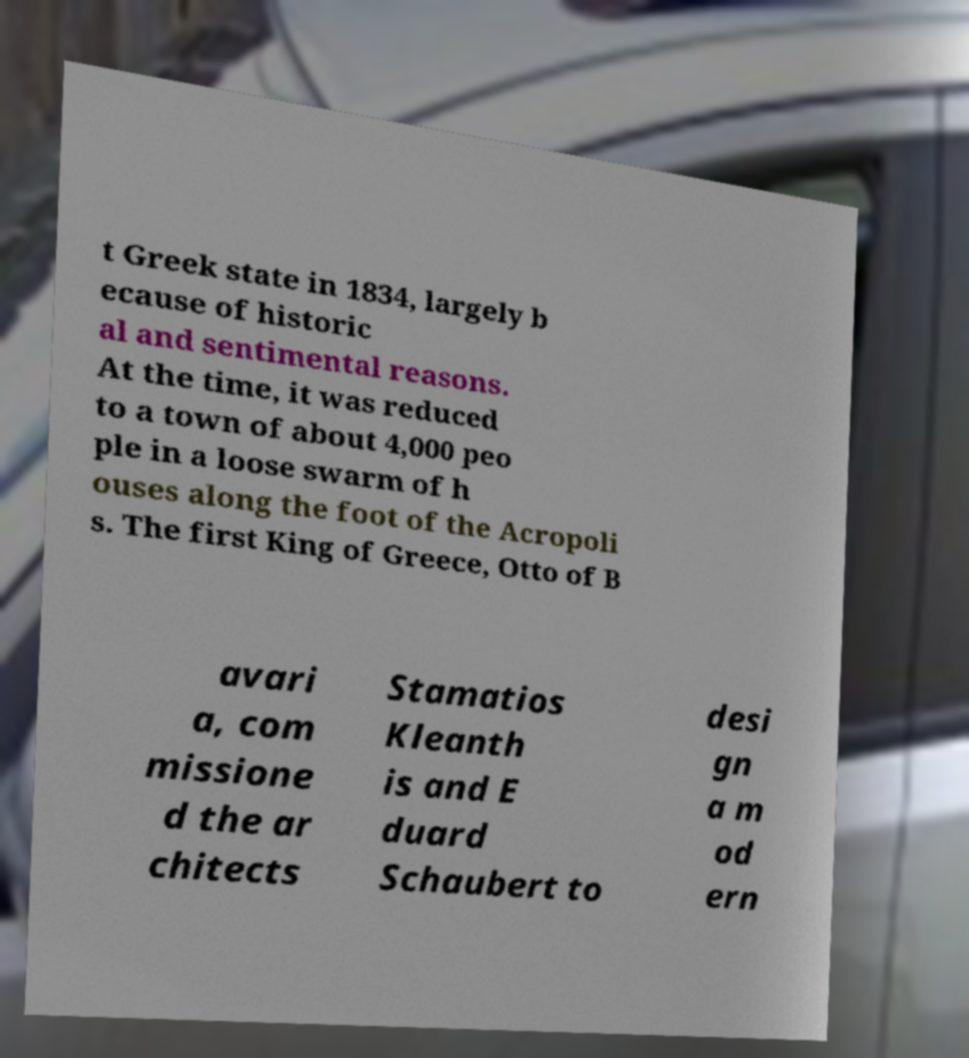For documentation purposes, I need the text within this image transcribed. Could you provide that? t Greek state in 1834, largely b ecause of historic al and sentimental reasons. At the time, it was reduced to a town of about 4,000 peo ple in a loose swarm of h ouses along the foot of the Acropoli s. The first King of Greece, Otto of B avari a, com missione d the ar chitects Stamatios Kleanth is and E duard Schaubert to desi gn a m od ern 